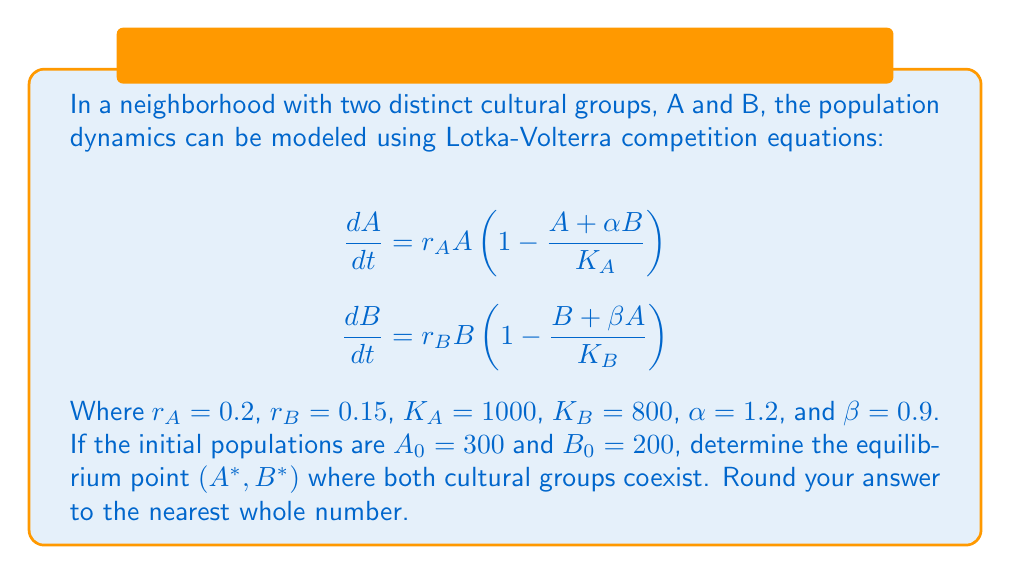Can you solve this math problem? To find the equilibrium point, we need to set both equations equal to zero and solve for A and B:

1) Set $\frac{dA}{dt} = 0$ and $\frac{dB}{dt} = 0$:

   $$0 = r_A A \left(1 - \frac{A + \alpha B}{K_A}\right)$$
   $$0 = r_B B \left(1 - \frac{B + \beta A}{K_B}\right)$$

2) Simplify (assuming A and B are not zero):

   $$1 - \frac{A + 1.2B}{1000} = 0$$
   $$1 - \frac{B + 0.9A}{800} = 0$$

3) Rearrange:

   $$A + 1.2B = 1000$$
   $$B + 0.9A = 800$$

4) Multiply the second equation by 1.2:

   $$A + 1.2B = 1000$$
   $$1.2B + 1.08A = 960$$

5) Subtract the second equation from the first:

   $$-0.08A = 40$$

6) Solve for A:

   $$A = 500$$

7) Substitute A into one of the equations from step 3:

   $$500 + 1.2B = 1000$$
   $$1.2B = 500$$
   $$B = 416.67$$

8) Round to the nearest whole number:

   A* = 500
   B* = 417

Therefore, the equilibrium point is (500, 417).
Answer: (500, 417) 